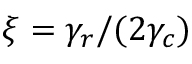Convert formula to latex. <formula><loc_0><loc_0><loc_500><loc_500>\xi = \gamma _ { r } / ( 2 \gamma _ { c } )</formula> 